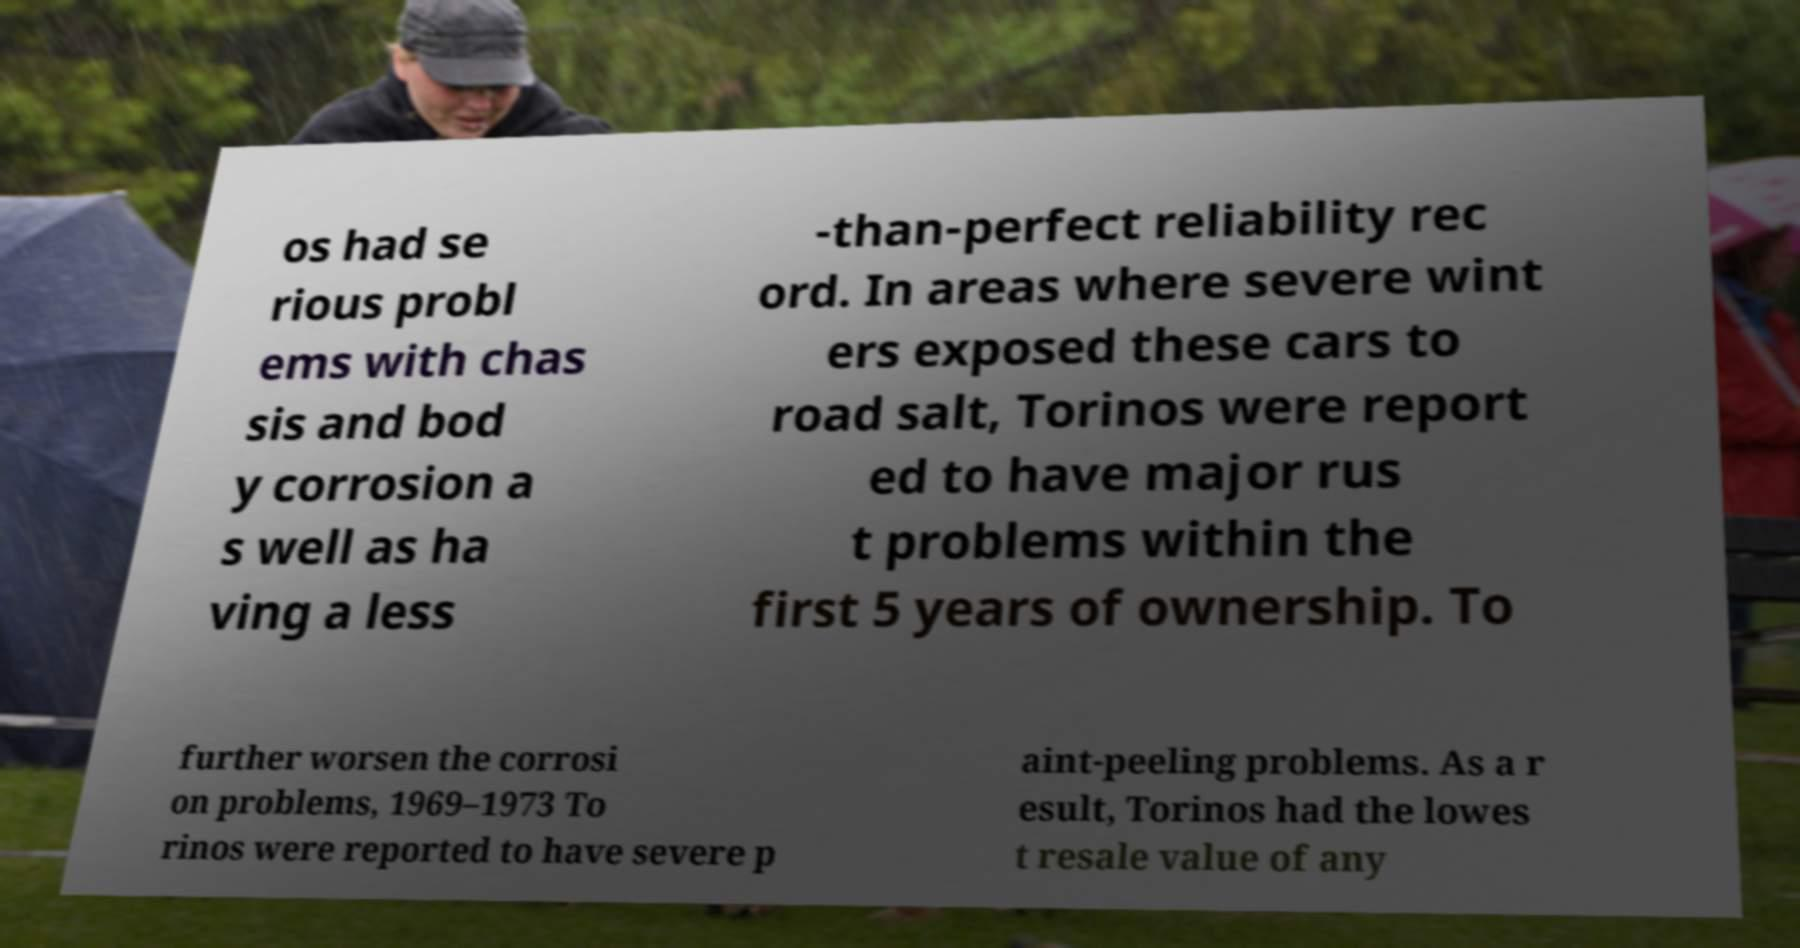Please identify and transcribe the text found in this image. os had se rious probl ems with chas sis and bod y corrosion a s well as ha ving a less -than-perfect reliability rec ord. In areas where severe wint ers exposed these cars to road salt, Torinos were report ed to have major rus t problems within the first 5 years of ownership. To further worsen the corrosi on problems, 1969–1973 To rinos were reported to have severe p aint-peeling problems. As a r esult, Torinos had the lowes t resale value of any 